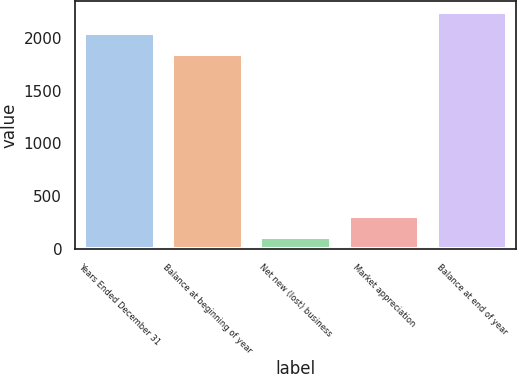Convert chart. <chart><loc_0><loc_0><loc_500><loc_500><bar_chart><fcel>Years Ended December 31<fcel>Balance at beginning of year<fcel>Net new (lost) business<fcel>Market appreciation<fcel>Balance at end of year<nl><fcel>2042.4<fcel>1845<fcel>112<fcel>309.4<fcel>2239.8<nl></chart> 